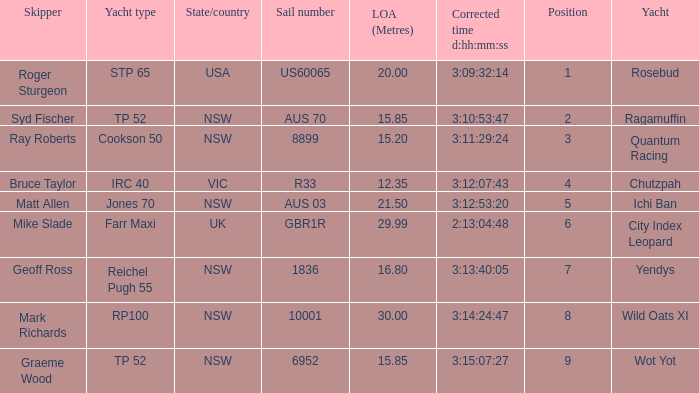What are all of the states or countries with a corrected time 3:13:40:05? NSW. 